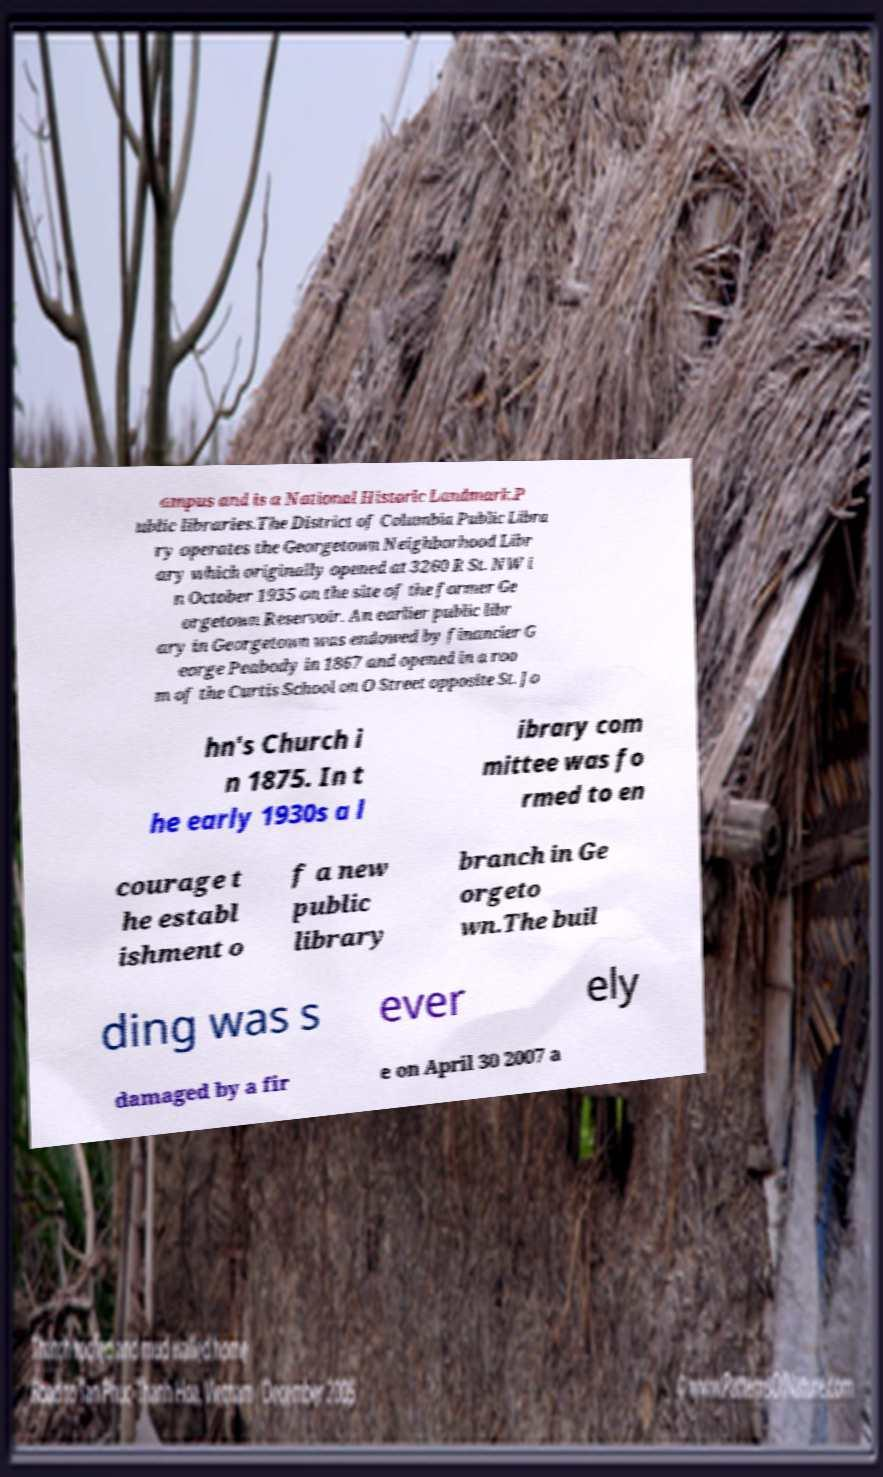What messages or text are displayed in this image? I need them in a readable, typed format. ampus and is a National Historic Landmark.P ublic libraries.The District of Columbia Public Libra ry operates the Georgetown Neighborhood Libr ary which originally opened at 3260 R St. NW i n October 1935 on the site of the former Ge orgetown Reservoir. An earlier public libr ary in Georgetown was endowed by financier G eorge Peabody in 1867 and opened in a roo m of the Curtis School on O Street opposite St. Jo hn's Church i n 1875. In t he early 1930s a l ibrary com mittee was fo rmed to en courage t he establ ishment o f a new public library branch in Ge orgeto wn.The buil ding was s ever ely damaged by a fir e on April 30 2007 a 